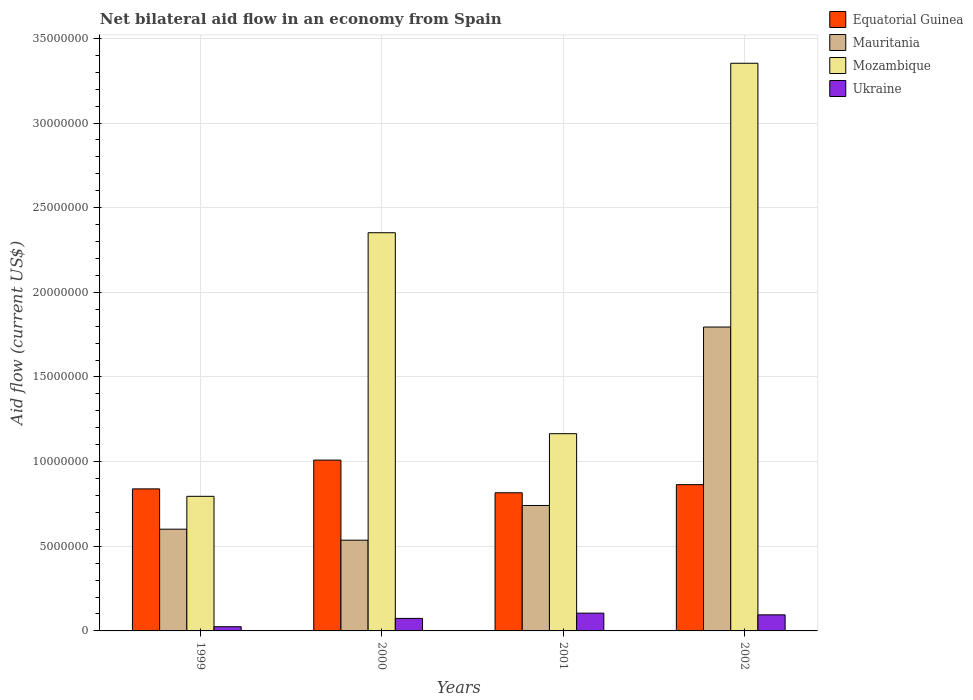Are the number of bars on each tick of the X-axis equal?
Your answer should be compact. Yes. How many bars are there on the 3rd tick from the left?
Offer a very short reply. 4. How many bars are there on the 3rd tick from the right?
Give a very brief answer. 4. What is the label of the 1st group of bars from the left?
Offer a very short reply. 1999. In how many cases, is the number of bars for a given year not equal to the number of legend labels?
Ensure brevity in your answer.  0. What is the net bilateral aid flow in Ukraine in 2000?
Provide a short and direct response. 7.40e+05. Across all years, what is the maximum net bilateral aid flow in Mauritania?
Provide a succinct answer. 1.80e+07. Across all years, what is the minimum net bilateral aid flow in Equatorial Guinea?
Keep it short and to the point. 8.16e+06. In which year was the net bilateral aid flow in Equatorial Guinea maximum?
Offer a terse response. 2000. What is the total net bilateral aid flow in Ukraine in the graph?
Make the answer very short. 2.99e+06. What is the difference between the net bilateral aid flow in Mozambique in 1999 and that in 2002?
Ensure brevity in your answer.  -2.56e+07. What is the difference between the net bilateral aid flow in Equatorial Guinea in 2000 and the net bilateral aid flow in Ukraine in 2002?
Offer a terse response. 9.14e+06. What is the average net bilateral aid flow in Equatorial Guinea per year?
Your answer should be very brief. 8.82e+06. In the year 2002, what is the difference between the net bilateral aid flow in Equatorial Guinea and net bilateral aid flow in Mozambique?
Provide a succinct answer. -2.49e+07. What is the ratio of the net bilateral aid flow in Mauritania in 1999 to that in 2000?
Your response must be concise. 1.12. Is the net bilateral aid flow in Mozambique in 2000 less than that in 2001?
Make the answer very short. No. Is the difference between the net bilateral aid flow in Equatorial Guinea in 1999 and 2001 greater than the difference between the net bilateral aid flow in Mozambique in 1999 and 2001?
Your answer should be compact. Yes. What is the difference between the highest and the second highest net bilateral aid flow in Mozambique?
Ensure brevity in your answer.  1.00e+07. What is the difference between the highest and the lowest net bilateral aid flow in Mozambique?
Ensure brevity in your answer.  2.56e+07. Is the sum of the net bilateral aid flow in Mozambique in 1999 and 2002 greater than the maximum net bilateral aid flow in Equatorial Guinea across all years?
Keep it short and to the point. Yes. Is it the case that in every year, the sum of the net bilateral aid flow in Ukraine and net bilateral aid flow in Mauritania is greater than the sum of net bilateral aid flow in Equatorial Guinea and net bilateral aid flow in Mozambique?
Ensure brevity in your answer.  No. What does the 3rd bar from the left in 2001 represents?
Ensure brevity in your answer.  Mozambique. What does the 2nd bar from the right in 1999 represents?
Keep it short and to the point. Mozambique. Is it the case that in every year, the sum of the net bilateral aid flow in Mauritania and net bilateral aid flow in Equatorial Guinea is greater than the net bilateral aid flow in Mozambique?
Provide a short and direct response. No. How many bars are there?
Offer a very short reply. 16. Are all the bars in the graph horizontal?
Offer a terse response. No. How many years are there in the graph?
Ensure brevity in your answer.  4. Are the values on the major ticks of Y-axis written in scientific E-notation?
Your answer should be compact. No. Does the graph contain grids?
Provide a succinct answer. Yes. What is the title of the graph?
Keep it short and to the point. Net bilateral aid flow in an economy from Spain. What is the label or title of the X-axis?
Keep it short and to the point. Years. What is the Aid flow (current US$) of Equatorial Guinea in 1999?
Your answer should be very brief. 8.39e+06. What is the Aid flow (current US$) in Mauritania in 1999?
Provide a succinct answer. 6.01e+06. What is the Aid flow (current US$) in Mozambique in 1999?
Offer a terse response. 7.95e+06. What is the Aid flow (current US$) of Ukraine in 1999?
Ensure brevity in your answer.  2.50e+05. What is the Aid flow (current US$) of Equatorial Guinea in 2000?
Your answer should be very brief. 1.01e+07. What is the Aid flow (current US$) in Mauritania in 2000?
Keep it short and to the point. 5.36e+06. What is the Aid flow (current US$) in Mozambique in 2000?
Your answer should be compact. 2.35e+07. What is the Aid flow (current US$) in Ukraine in 2000?
Give a very brief answer. 7.40e+05. What is the Aid flow (current US$) in Equatorial Guinea in 2001?
Your answer should be compact. 8.16e+06. What is the Aid flow (current US$) in Mauritania in 2001?
Ensure brevity in your answer.  7.41e+06. What is the Aid flow (current US$) of Mozambique in 2001?
Your answer should be compact. 1.16e+07. What is the Aid flow (current US$) in Ukraine in 2001?
Offer a very short reply. 1.05e+06. What is the Aid flow (current US$) of Equatorial Guinea in 2002?
Your answer should be compact. 8.64e+06. What is the Aid flow (current US$) in Mauritania in 2002?
Offer a terse response. 1.80e+07. What is the Aid flow (current US$) of Mozambique in 2002?
Make the answer very short. 3.35e+07. What is the Aid flow (current US$) of Ukraine in 2002?
Provide a succinct answer. 9.50e+05. Across all years, what is the maximum Aid flow (current US$) of Equatorial Guinea?
Offer a very short reply. 1.01e+07. Across all years, what is the maximum Aid flow (current US$) of Mauritania?
Give a very brief answer. 1.80e+07. Across all years, what is the maximum Aid flow (current US$) of Mozambique?
Provide a succinct answer. 3.35e+07. Across all years, what is the maximum Aid flow (current US$) of Ukraine?
Your answer should be compact. 1.05e+06. Across all years, what is the minimum Aid flow (current US$) in Equatorial Guinea?
Provide a short and direct response. 8.16e+06. Across all years, what is the minimum Aid flow (current US$) of Mauritania?
Your answer should be compact. 5.36e+06. Across all years, what is the minimum Aid flow (current US$) of Mozambique?
Keep it short and to the point. 7.95e+06. Across all years, what is the minimum Aid flow (current US$) of Ukraine?
Keep it short and to the point. 2.50e+05. What is the total Aid flow (current US$) of Equatorial Guinea in the graph?
Your answer should be compact. 3.53e+07. What is the total Aid flow (current US$) in Mauritania in the graph?
Your answer should be very brief. 3.67e+07. What is the total Aid flow (current US$) of Mozambique in the graph?
Give a very brief answer. 7.66e+07. What is the total Aid flow (current US$) in Ukraine in the graph?
Make the answer very short. 2.99e+06. What is the difference between the Aid flow (current US$) in Equatorial Guinea in 1999 and that in 2000?
Your answer should be compact. -1.70e+06. What is the difference between the Aid flow (current US$) of Mauritania in 1999 and that in 2000?
Give a very brief answer. 6.50e+05. What is the difference between the Aid flow (current US$) of Mozambique in 1999 and that in 2000?
Offer a terse response. -1.56e+07. What is the difference between the Aid flow (current US$) in Ukraine in 1999 and that in 2000?
Give a very brief answer. -4.90e+05. What is the difference between the Aid flow (current US$) in Equatorial Guinea in 1999 and that in 2001?
Your answer should be very brief. 2.30e+05. What is the difference between the Aid flow (current US$) in Mauritania in 1999 and that in 2001?
Ensure brevity in your answer.  -1.40e+06. What is the difference between the Aid flow (current US$) in Mozambique in 1999 and that in 2001?
Keep it short and to the point. -3.70e+06. What is the difference between the Aid flow (current US$) in Ukraine in 1999 and that in 2001?
Provide a succinct answer. -8.00e+05. What is the difference between the Aid flow (current US$) in Equatorial Guinea in 1999 and that in 2002?
Make the answer very short. -2.50e+05. What is the difference between the Aid flow (current US$) of Mauritania in 1999 and that in 2002?
Your answer should be compact. -1.19e+07. What is the difference between the Aid flow (current US$) in Mozambique in 1999 and that in 2002?
Keep it short and to the point. -2.56e+07. What is the difference between the Aid flow (current US$) of Ukraine in 1999 and that in 2002?
Make the answer very short. -7.00e+05. What is the difference between the Aid flow (current US$) of Equatorial Guinea in 2000 and that in 2001?
Your answer should be compact. 1.93e+06. What is the difference between the Aid flow (current US$) of Mauritania in 2000 and that in 2001?
Give a very brief answer. -2.05e+06. What is the difference between the Aid flow (current US$) in Mozambique in 2000 and that in 2001?
Provide a succinct answer. 1.19e+07. What is the difference between the Aid flow (current US$) of Ukraine in 2000 and that in 2001?
Make the answer very short. -3.10e+05. What is the difference between the Aid flow (current US$) of Equatorial Guinea in 2000 and that in 2002?
Keep it short and to the point. 1.45e+06. What is the difference between the Aid flow (current US$) of Mauritania in 2000 and that in 2002?
Make the answer very short. -1.26e+07. What is the difference between the Aid flow (current US$) of Mozambique in 2000 and that in 2002?
Provide a succinct answer. -1.00e+07. What is the difference between the Aid flow (current US$) in Equatorial Guinea in 2001 and that in 2002?
Provide a short and direct response. -4.80e+05. What is the difference between the Aid flow (current US$) in Mauritania in 2001 and that in 2002?
Your response must be concise. -1.05e+07. What is the difference between the Aid flow (current US$) of Mozambique in 2001 and that in 2002?
Your answer should be very brief. -2.19e+07. What is the difference between the Aid flow (current US$) of Equatorial Guinea in 1999 and the Aid flow (current US$) of Mauritania in 2000?
Offer a terse response. 3.03e+06. What is the difference between the Aid flow (current US$) of Equatorial Guinea in 1999 and the Aid flow (current US$) of Mozambique in 2000?
Ensure brevity in your answer.  -1.51e+07. What is the difference between the Aid flow (current US$) of Equatorial Guinea in 1999 and the Aid flow (current US$) of Ukraine in 2000?
Offer a terse response. 7.65e+06. What is the difference between the Aid flow (current US$) of Mauritania in 1999 and the Aid flow (current US$) of Mozambique in 2000?
Your answer should be compact. -1.75e+07. What is the difference between the Aid flow (current US$) in Mauritania in 1999 and the Aid flow (current US$) in Ukraine in 2000?
Offer a very short reply. 5.27e+06. What is the difference between the Aid flow (current US$) in Mozambique in 1999 and the Aid flow (current US$) in Ukraine in 2000?
Make the answer very short. 7.21e+06. What is the difference between the Aid flow (current US$) in Equatorial Guinea in 1999 and the Aid flow (current US$) in Mauritania in 2001?
Make the answer very short. 9.80e+05. What is the difference between the Aid flow (current US$) in Equatorial Guinea in 1999 and the Aid flow (current US$) in Mozambique in 2001?
Your answer should be compact. -3.26e+06. What is the difference between the Aid flow (current US$) in Equatorial Guinea in 1999 and the Aid flow (current US$) in Ukraine in 2001?
Give a very brief answer. 7.34e+06. What is the difference between the Aid flow (current US$) of Mauritania in 1999 and the Aid flow (current US$) of Mozambique in 2001?
Make the answer very short. -5.64e+06. What is the difference between the Aid flow (current US$) of Mauritania in 1999 and the Aid flow (current US$) of Ukraine in 2001?
Your answer should be compact. 4.96e+06. What is the difference between the Aid flow (current US$) of Mozambique in 1999 and the Aid flow (current US$) of Ukraine in 2001?
Offer a terse response. 6.90e+06. What is the difference between the Aid flow (current US$) in Equatorial Guinea in 1999 and the Aid flow (current US$) in Mauritania in 2002?
Provide a short and direct response. -9.56e+06. What is the difference between the Aid flow (current US$) of Equatorial Guinea in 1999 and the Aid flow (current US$) of Mozambique in 2002?
Your response must be concise. -2.51e+07. What is the difference between the Aid flow (current US$) in Equatorial Guinea in 1999 and the Aid flow (current US$) in Ukraine in 2002?
Ensure brevity in your answer.  7.44e+06. What is the difference between the Aid flow (current US$) in Mauritania in 1999 and the Aid flow (current US$) in Mozambique in 2002?
Offer a very short reply. -2.75e+07. What is the difference between the Aid flow (current US$) of Mauritania in 1999 and the Aid flow (current US$) of Ukraine in 2002?
Keep it short and to the point. 5.06e+06. What is the difference between the Aid flow (current US$) in Equatorial Guinea in 2000 and the Aid flow (current US$) in Mauritania in 2001?
Make the answer very short. 2.68e+06. What is the difference between the Aid flow (current US$) of Equatorial Guinea in 2000 and the Aid flow (current US$) of Mozambique in 2001?
Offer a very short reply. -1.56e+06. What is the difference between the Aid flow (current US$) in Equatorial Guinea in 2000 and the Aid flow (current US$) in Ukraine in 2001?
Provide a short and direct response. 9.04e+06. What is the difference between the Aid flow (current US$) in Mauritania in 2000 and the Aid flow (current US$) in Mozambique in 2001?
Provide a short and direct response. -6.29e+06. What is the difference between the Aid flow (current US$) in Mauritania in 2000 and the Aid flow (current US$) in Ukraine in 2001?
Offer a terse response. 4.31e+06. What is the difference between the Aid flow (current US$) in Mozambique in 2000 and the Aid flow (current US$) in Ukraine in 2001?
Make the answer very short. 2.25e+07. What is the difference between the Aid flow (current US$) in Equatorial Guinea in 2000 and the Aid flow (current US$) in Mauritania in 2002?
Provide a short and direct response. -7.86e+06. What is the difference between the Aid flow (current US$) of Equatorial Guinea in 2000 and the Aid flow (current US$) of Mozambique in 2002?
Offer a terse response. -2.34e+07. What is the difference between the Aid flow (current US$) in Equatorial Guinea in 2000 and the Aid flow (current US$) in Ukraine in 2002?
Your answer should be very brief. 9.14e+06. What is the difference between the Aid flow (current US$) in Mauritania in 2000 and the Aid flow (current US$) in Mozambique in 2002?
Make the answer very short. -2.82e+07. What is the difference between the Aid flow (current US$) of Mauritania in 2000 and the Aid flow (current US$) of Ukraine in 2002?
Make the answer very short. 4.41e+06. What is the difference between the Aid flow (current US$) in Mozambique in 2000 and the Aid flow (current US$) in Ukraine in 2002?
Provide a short and direct response. 2.26e+07. What is the difference between the Aid flow (current US$) of Equatorial Guinea in 2001 and the Aid flow (current US$) of Mauritania in 2002?
Give a very brief answer. -9.79e+06. What is the difference between the Aid flow (current US$) of Equatorial Guinea in 2001 and the Aid flow (current US$) of Mozambique in 2002?
Keep it short and to the point. -2.54e+07. What is the difference between the Aid flow (current US$) of Equatorial Guinea in 2001 and the Aid flow (current US$) of Ukraine in 2002?
Your response must be concise. 7.21e+06. What is the difference between the Aid flow (current US$) in Mauritania in 2001 and the Aid flow (current US$) in Mozambique in 2002?
Make the answer very short. -2.61e+07. What is the difference between the Aid flow (current US$) in Mauritania in 2001 and the Aid flow (current US$) in Ukraine in 2002?
Make the answer very short. 6.46e+06. What is the difference between the Aid flow (current US$) of Mozambique in 2001 and the Aid flow (current US$) of Ukraine in 2002?
Offer a very short reply. 1.07e+07. What is the average Aid flow (current US$) of Equatorial Guinea per year?
Your response must be concise. 8.82e+06. What is the average Aid flow (current US$) in Mauritania per year?
Offer a terse response. 9.18e+06. What is the average Aid flow (current US$) of Mozambique per year?
Your answer should be very brief. 1.92e+07. What is the average Aid flow (current US$) of Ukraine per year?
Provide a short and direct response. 7.48e+05. In the year 1999, what is the difference between the Aid flow (current US$) of Equatorial Guinea and Aid flow (current US$) of Mauritania?
Provide a succinct answer. 2.38e+06. In the year 1999, what is the difference between the Aid flow (current US$) of Equatorial Guinea and Aid flow (current US$) of Ukraine?
Provide a short and direct response. 8.14e+06. In the year 1999, what is the difference between the Aid flow (current US$) in Mauritania and Aid flow (current US$) in Mozambique?
Provide a short and direct response. -1.94e+06. In the year 1999, what is the difference between the Aid flow (current US$) in Mauritania and Aid flow (current US$) in Ukraine?
Give a very brief answer. 5.76e+06. In the year 1999, what is the difference between the Aid flow (current US$) of Mozambique and Aid flow (current US$) of Ukraine?
Your response must be concise. 7.70e+06. In the year 2000, what is the difference between the Aid flow (current US$) of Equatorial Guinea and Aid flow (current US$) of Mauritania?
Give a very brief answer. 4.73e+06. In the year 2000, what is the difference between the Aid flow (current US$) of Equatorial Guinea and Aid flow (current US$) of Mozambique?
Ensure brevity in your answer.  -1.34e+07. In the year 2000, what is the difference between the Aid flow (current US$) of Equatorial Guinea and Aid flow (current US$) of Ukraine?
Your response must be concise. 9.35e+06. In the year 2000, what is the difference between the Aid flow (current US$) of Mauritania and Aid flow (current US$) of Mozambique?
Provide a succinct answer. -1.82e+07. In the year 2000, what is the difference between the Aid flow (current US$) of Mauritania and Aid flow (current US$) of Ukraine?
Offer a very short reply. 4.62e+06. In the year 2000, what is the difference between the Aid flow (current US$) in Mozambique and Aid flow (current US$) in Ukraine?
Ensure brevity in your answer.  2.28e+07. In the year 2001, what is the difference between the Aid flow (current US$) of Equatorial Guinea and Aid flow (current US$) of Mauritania?
Your answer should be very brief. 7.50e+05. In the year 2001, what is the difference between the Aid flow (current US$) of Equatorial Guinea and Aid flow (current US$) of Mozambique?
Make the answer very short. -3.49e+06. In the year 2001, what is the difference between the Aid flow (current US$) in Equatorial Guinea and Aid flow (current US$) in Ukraine?
Ensure brevity in your answer.  7.11e+06. In the year 2001, what is the difference between the Aid flow (current US$) of Mauritania and Aid flow (current US$) of Mozambique?
Keep it short and to the point. -4.24e+06. In the year 2001, what is the difference between the Aid flow (current US$) of Mauritania and Aid flow (current US$) of Ukraine?
Ensure brevity in your answer.  6.36e+06. In the year 2001, what is the difference between the Aid flow (current US$) of Mozambique and Aid flow (current US$) of Ukraine?
Give a very brief answer. 1.06e+07. In the year 2002, what is the difference between the Aid flow (current US$) of Equatorial Guinea and Aid flow (current US$) of Mauritania?
Offer a very short reply. -9.31e+06. In the year 2002, what is the difference between the Aid flow (current US$) in Equatorial Guinea and Aid flow (current US$) in Mozambique?
Provide a succinct answer. -2.49e+07. In the year 2002, what is the difference between the Aid flow (current US$) of Equatorial Guinea and Aid flow (current US$) of Ukraine?
Your answer should be very brief. 7.69e+06. In the year 2002, what is the difference between the Aid flow (current US$) of Mauritania and Aid flow (current US$) of Mozambique?
Your response must be concise. -1.56e+07. In the year 2002, what is the difference between the Aid flow (current US$) in Mauritania and Aid flow (current US$) in Ukraine?
Provide a succinct answer. 1.70e+07. In the year 2002, what is the difference between the Aid flow (current US$) of Mozambique and Aid flow (current US$) of Ukraine?
Keep it short and to the point. 3.26e+07. What is the ratio of the Aid flow (current US$) of Equatorial Guinea in 1999 to that in 2000?
Give a very brief answer. 0.83. What is the ratio of the Aid flow (current US$) in Mauritania in 1999 to that in 2000?
Provide a short and direct response. 1.12. What is the ratio of the Aid flow (current US$) of Mozambique in 1999 to that in 2000?
Your answer should be compact. 0.34. What is the ratio of the Aid flow (current US$) in Ukraine in 1999 to that in 2000?
Offer a terse response. 0.34. What is the ratio of the Aid flow (current US$) of Equatorial Guinea in 1999 to that in 2001?
Provide a succinct answer. 1.03. What is the ratio of the Aid flow (current US$) in Mauritania in 1999 to that in 2001?
Give a very brief answer. 0.81. What is the ratio of the Aid flow (current US$) in Mozambique in 1999 to that in 2001?
Your answer should be very brief. 0.68. What is the ratio of the Aid flow (current US$) of Ukraine in 1999 to that in 2001?
Your answer should be compact. 0.24. What is the ratio of the Aid flow (current US$) of Equatorial Guinea in 1999 to that in 2002?
Make the answer very short. 0.97. What is the ratio of the Aid flow (current US$) in Mauritania in 1999 to that in 2002?
Offer a terse response. 0.33. What is the ratio of the Aid flow (current US$) of Mozambique in 1999 to that in 2002?
Your answer should be compact. 0.24. What is the ratio of the Aid flow (current US$) of Ukraine in 1999 to that in 2002?
Provide a short and direct response. 0.26. What is the ratio of the Aid flow (current US$) in Equatorial Guinea in 2000 to that in 2001?
Your response must be concise. 1.24. What is the ratio of the Aid flow (current US$) of Mauritania in 2000 to that in 2001?
Your response must be concise. 0.72. What is the ratio of the Aid flow (current US$) in Mozambique in 2000 to that in 2001?
Keep it short and to the point. 2.02. What is the ratio of the Aid flow (current US$) in Ukraine in 2000 to that in 2001?
Offer a terse response. 0.7. What is the ratio of the Aid flow (current US$) in Equatorial Guinea in 2000 to that in 2002?
Your answer should be very brief. 1.17. What is the ratio of the Aid flow (current US$) of Mauritania in 2000 to that in 2002?
Keep it short and to the point. 0.3. What is the ratio of the Aid flow (current US$) of Mozambique in 2000 to that in 2002?
Your response must be concise. 0.7. What is the ratio of the Aid flow (current US$) of Ukraine in 2000 to that in 2002?
Provide a short and direct response. 0.78. What is the ratio of the Aid flow (current US$) of Equatorial Guinea in 2001 to that in 2002?
Keep it short and to the point. 0.94. What is the ratio of the Aid flow (current US$) in Mauritania in 2001 to that in 2002?
Your answer should be compact. 0.41. What is the ratio of the Aid flow (current US$) of Mozambique in 2001 to that in 2002?
Provide a short and direct response. 0.35. What is the ratio of the Aid flow (current US$) in Ukraine in 2001 to that in 2002?
Keep it short and to the point. 1.11. What is the difference between the highest and the second highest Aid flow (current US$) of Equatorial Guinea?
Make the answer very short. 1.45e+06. What is the difference between the highest and the second highest Aid flow (current US$) in Mauritania?
Offer a terse response. 1.05e+07. What is the difference between the highest and the second highest Aid flow (current US$) in Mozambique?
Keep it short and to the point. 1.00e+07. What is the difference between the highest and the lowest Aid flow (current US$) of Equatorial Guinea?
Give a very brief answer. 1.93e+06. What is the difference between the highest and the lowest Aid flow (current US$) in Mauritania?
Give a very brief answer. 1.26e+07. What is the difference between the highest and the lowest Aid flow (current US$) of Mozambique?
Offer a very short reply. 2.56e+07. 